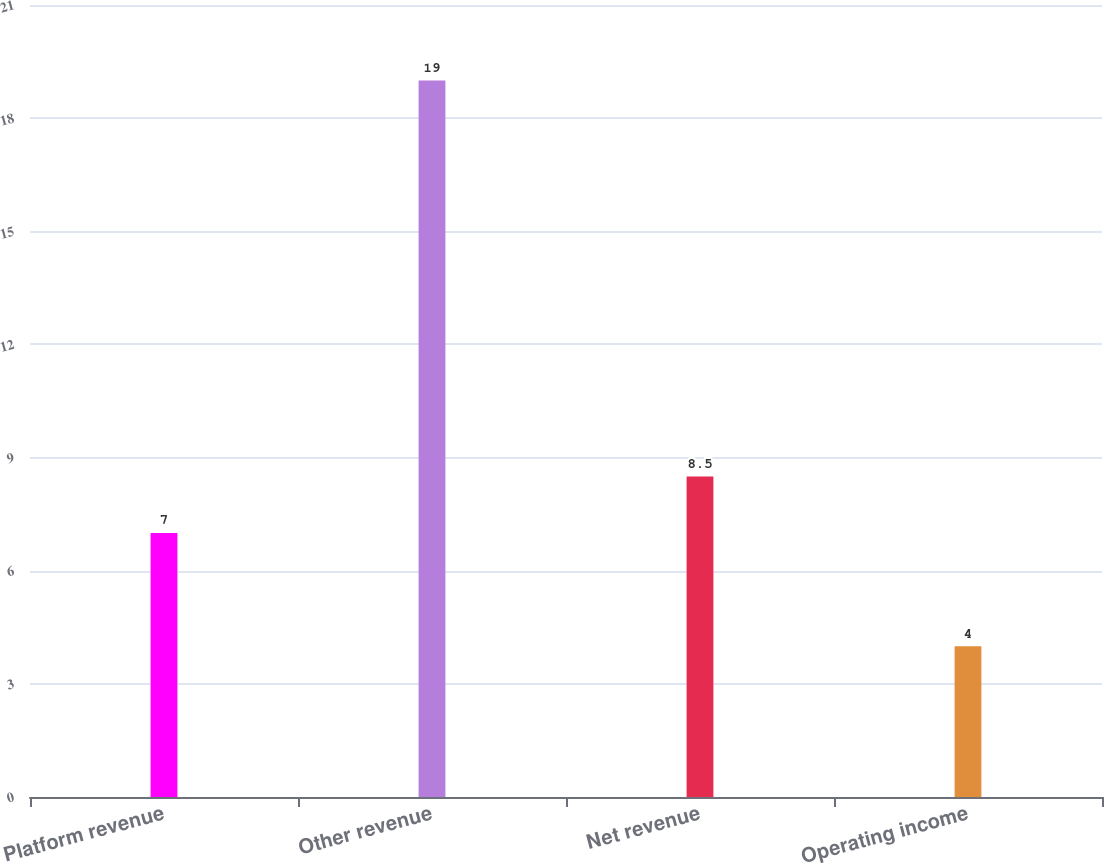Convert chart. <chart><loc_0><loc_0><loc_500><loc_500><bar_chart><fcel>Platform revenue<fcel>Other revenue<fcel>Net revenue<fcel>Operating income<nl><fcel>7<fcel>19<fcel>8.5<fcel>4<nl></chart> 